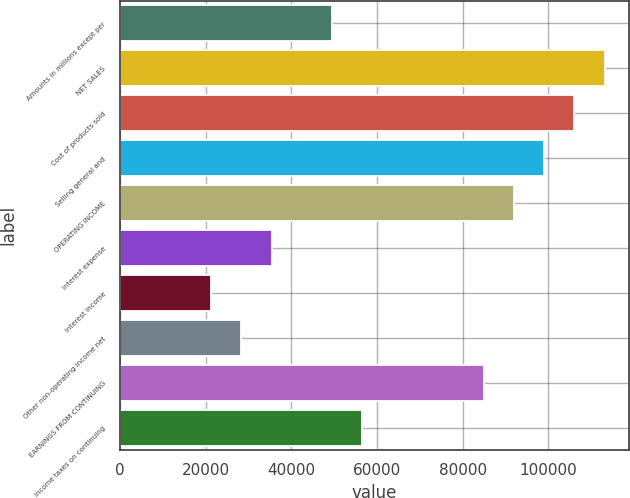Convert chart. <chart><loc_0><loc_0><loc_500><loc_500><bar_chart><fcel>Amounts in millions except per<fcel>NET SALES<fcel>Cost of products sold<fcel>Selling general and<fcel>OPERATING INCOME<fcel>Interest expense<fcel>Interest income<fcel>Other non-operating income net<fcel>EARNINGS FROM CONTINUING<fcel>Income taxes on continuing<nl><fcel>49524.4<fcel>113198<fcel>106123<fcel>99048.5<fcel>91973.6<fcel>35374.7<fcel>21225<fcel>28299.9<fcel>84898.7<fcel>56599.3<nl></chart> 